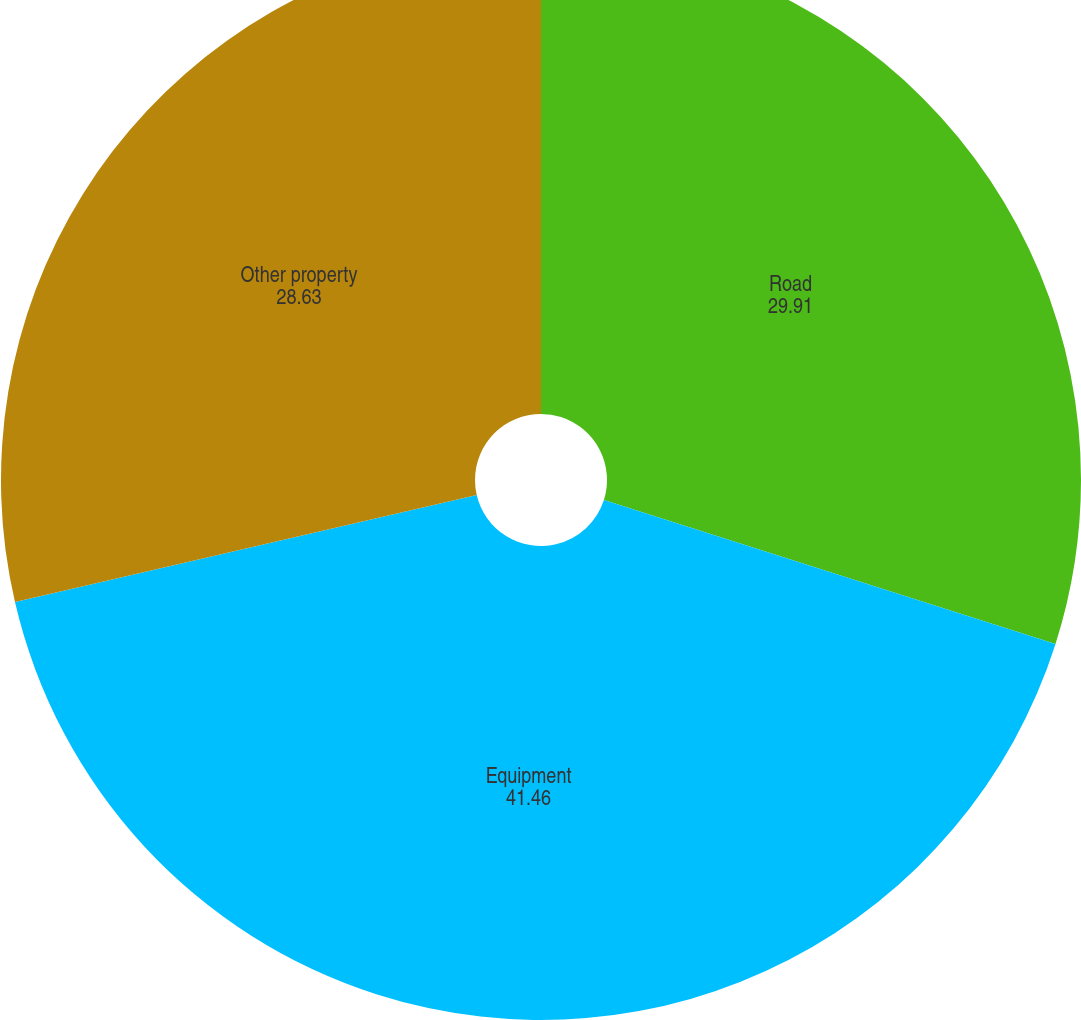<chart> <loc_0><loc_0><loc_500><loc_500><pie_chart><fcel>Road<fcel>Equipment<fcel>Other property<nl><fcel>29.91%<fcel>41.46%<fcel>28.63%<nl></chart> 